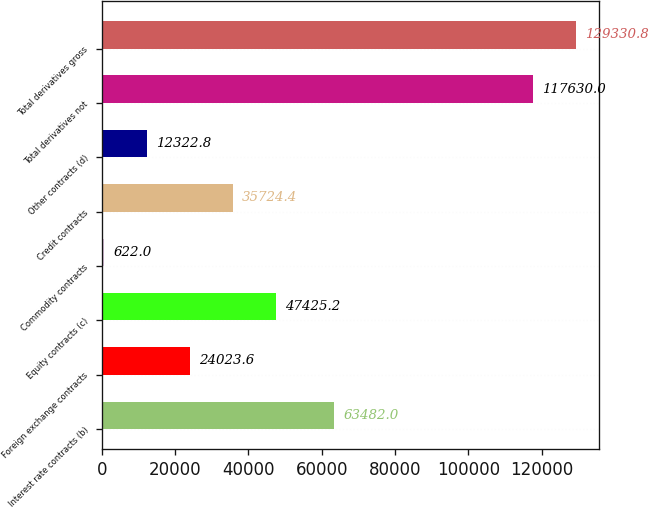Convert chart. <chart><loc_0><loc_0><loc_500><loc_500><bar_chart><fcel>Interest rate contracts (b)<fcel>Foreign exchange contracts<fcel>Equity contracts (c)<fcel>Commodity contracts<fcel>Credit contracts<fcel>Other contracts (d)<fcel>Total derivatives not<fcel>Total derivatives gross<nl><fcel>63482<fcel>24023.6<fcel>47425.2<fcel>622<fcel>35724.4<fcel>12322.8<fcel>117630<fcel>129331<nl></chart> 